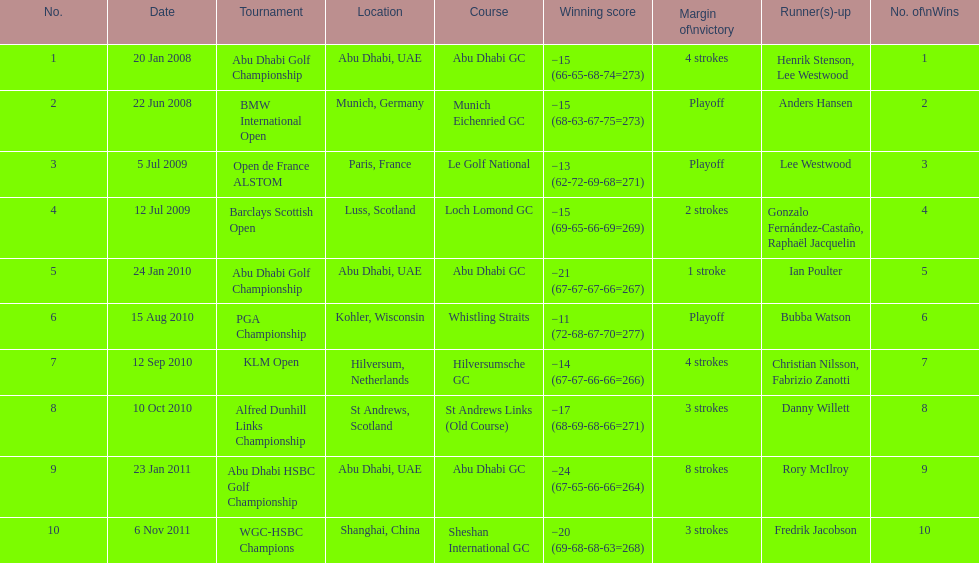How many tournaments has he won by 3 or more strokes? 5. 